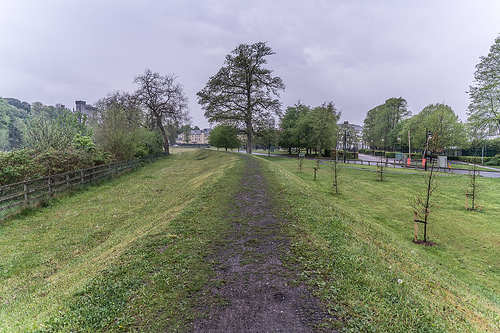<image>
Is there a tree on the path? No. The tree is not positioned on the path. They may be near each other, but the tree is not supported by or resting on top of the path. 